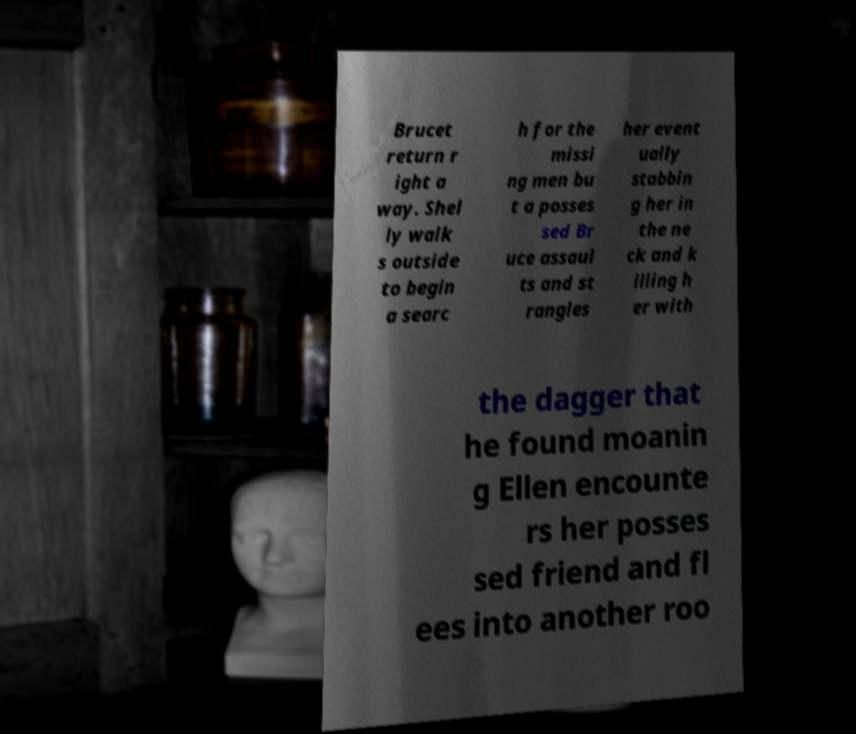For documentation purposes, I need the text within this image transcribed. Could you provide that? Brucet return r ight a way. Shel ly walk s outside to begin a searc h for the missi ng men bu t a posses sed Br uce assaul ts and st rangles her event ually stabbin g her in the ne ck and k illing h er with the dagger that he found moanin g Ellen encounte rs her posses sed friend and fl ees into another roo 